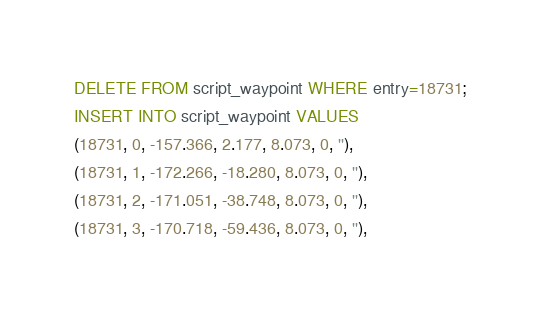<code> <loc_0><loc_0><loc_500><loc_500><_SQL_>DELETE FROM script_waypoint WHERE entry=18731;
INSERT INTO script_waypoint VALUES
(18731, 0, -157.366, 2.177, 8.073, 0, ''),
(18731, 1, -172.266, -18.280, 8.073, 0, ''),
(18731, 2, -171.051, -38.748, 8.073, 0, ''),
(18731, 3, -170.718, -59.436, 8.073, 0, ''),</code> 